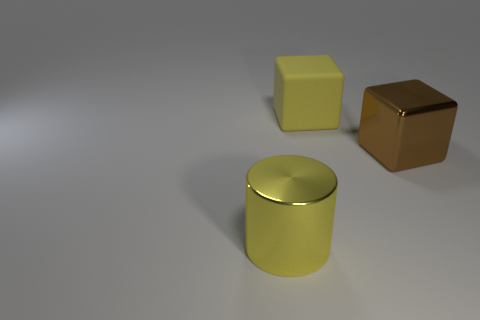What textures are visible on the objects and what do they tell us about the materials? The textures on the objects are quite smooth, with subtle specular highlights, especially on the cylindrical container. This implies that the materials from which the objects are made have a somewhat reflective surface, such as polished metal or a type of plastic with a glossy finish. These characteristics suggest that these objects are rigid and solid. 